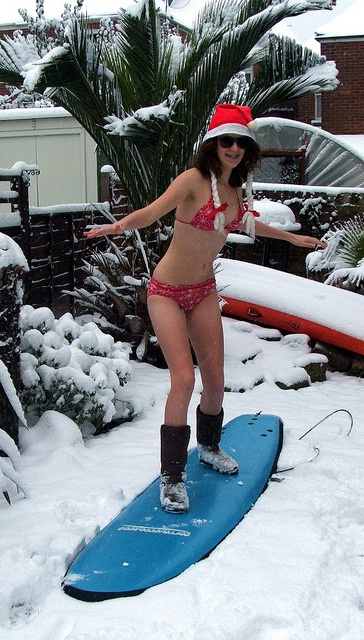Describe the objects in this image and their specific colors. I can see people in white, brown, black, and maroon tones and surfboard in white, teal, and blue tones in this image. 